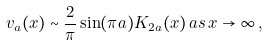<formula> <loc_0><loc_0><loc_500><loc_500>v _ { a } ( x ) \sim \frac { 2 } { \pi } \sin ( \pi a ) K _ { 2 a } ( x ) \, a s \, x \to \infty \, ,</formula> 